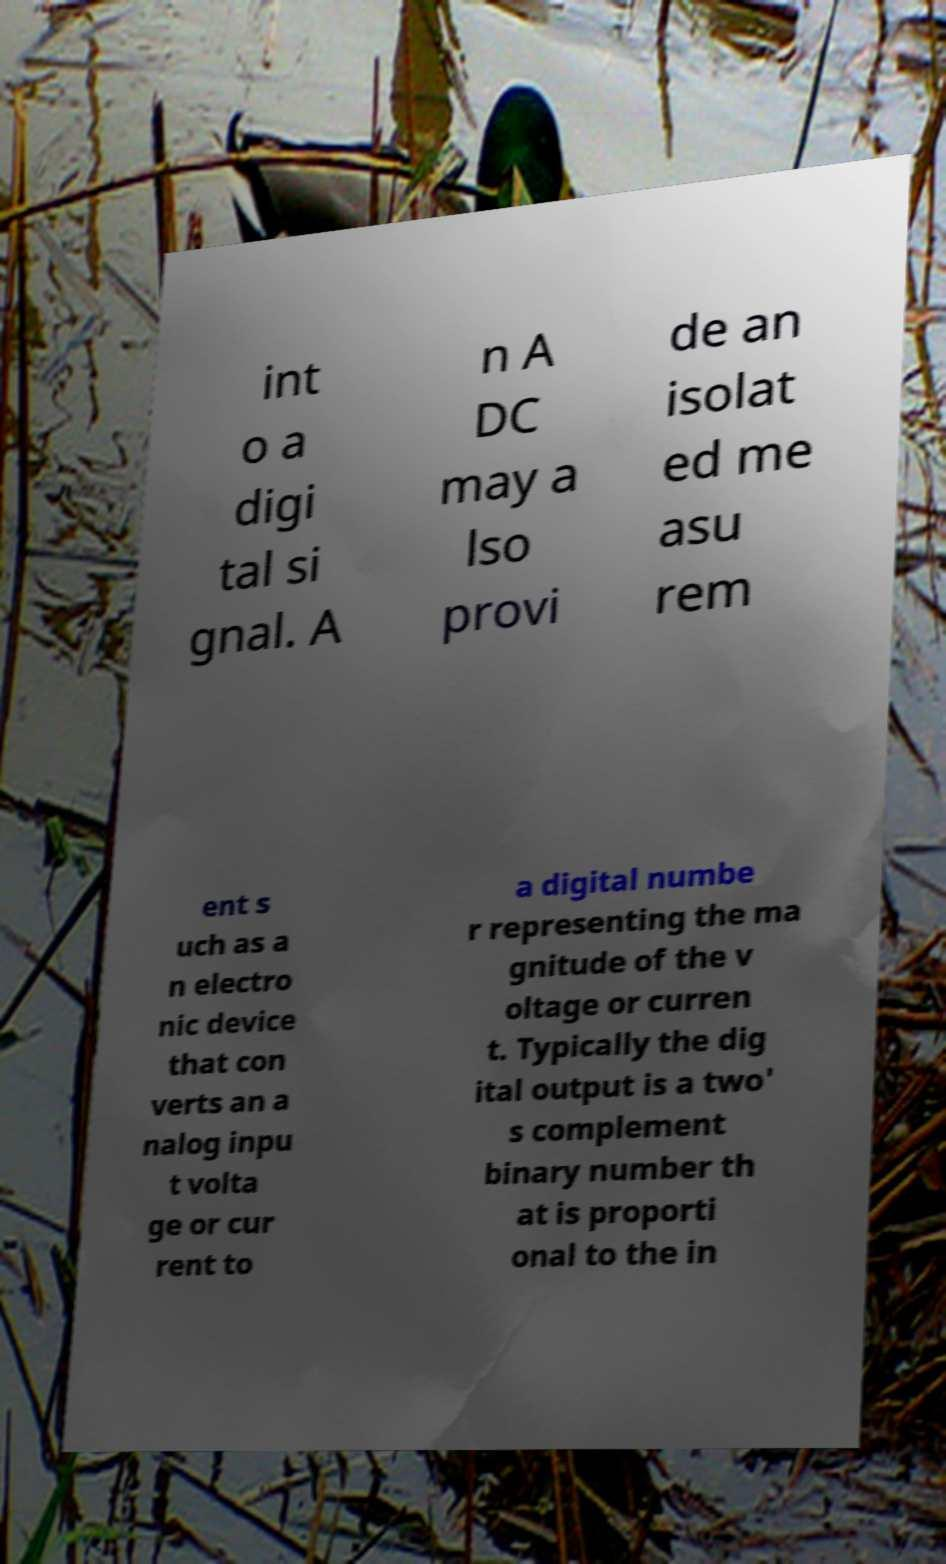For documentation purposes, I need the text within this image transcribed. Could you provide that? int o a digi tal si gnal. A n A DC may a lso provi de an isolat ed me asu rem ent s uch as a n electro nic device that con verts an a nalog inpu t volta ge or cur rent to a digital numbe r representing the ma gnitude of the v oltage or curren t. Typically the dig ital output is a two' s complement binary number th at is proporti onal to the in 